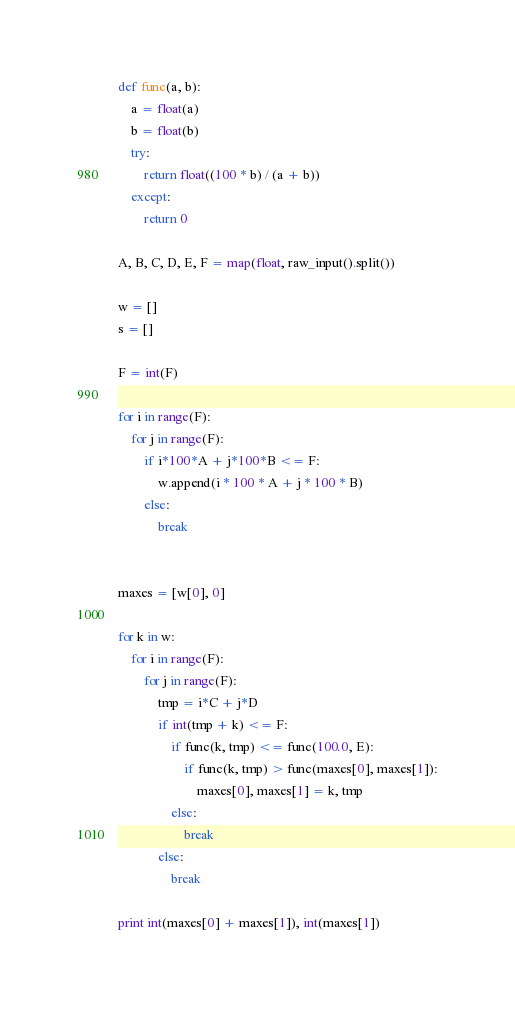<code> <loc_0><loc_0><loc_500><loc_500><_Python_>def func(a, b):
    a = float(a)
    b = float(b)
    try:
        return float((100 * b) / (a + b))
    except:
        return 0

A, B, C, D, E, F = map(float, raw_input().split())

w = []
s = []

F = int(F)

for i in range(F):
    for j in range(F):
        if i*100*A + j*100*B <= F:
            w.append(i * 100 * A + j * 100 * B)
        else:
            break


maxes = [w[0], 0]

for k in w:
    for i in range(F):
        for j in range(F):
            tmp = i*C + j*D
            if int(tmp + k) <= F:
                if func(k, tmp) <= func(100.0, E):
                    if func(k, tmp) > func(maxes[0], maxes[1]):
                        maxes[0], maxes[1] = k, tmp
                else:
                    break
            else:
            	break

print int(maxes[0] + maxes[1]), int(maxes[1])</code> 